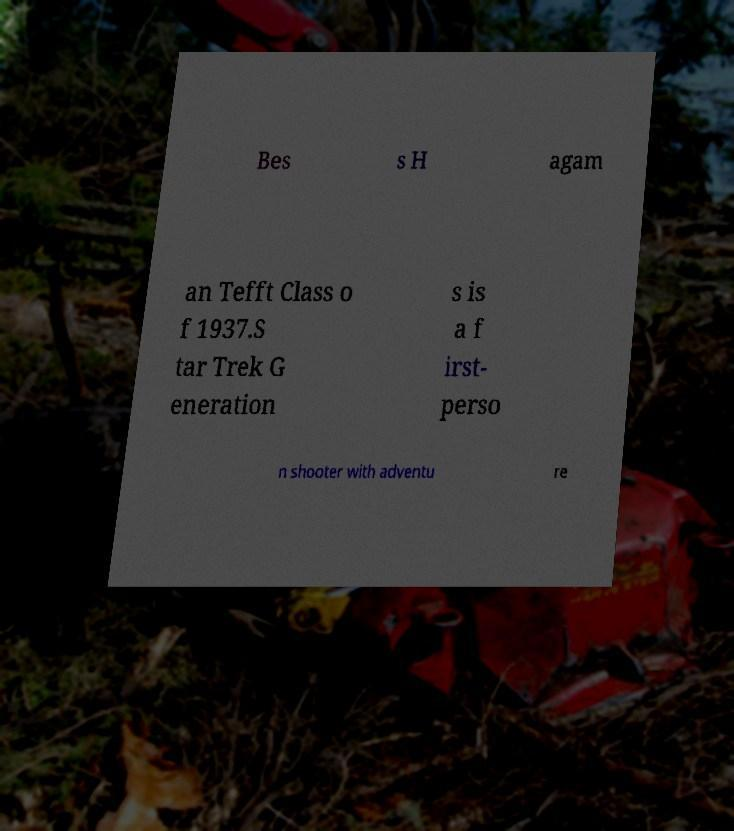Can you accurately transcribe the text from the provided image for me? Bes s H agam an Tefft Class o f 1937.S tar Trek G eneration s is a f irst- perso n shooter with adventu re 